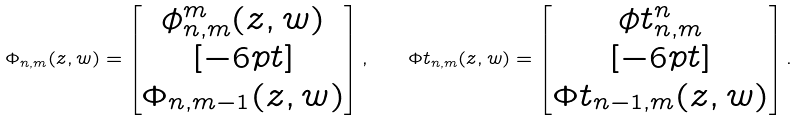<formula> <loc_0><loc_0><loc_500><loc_500>\Phi _ { n , m } ( z , w ) = \left [ \begin{matrix} \phi _ { n , m } ^ { m } ( z , w ) \\ [ - 6 p t ] \\ \Phi _ { n , m - 1 } ( z , w ) \end{matrix} \right ] , \quad \Phi t _ { n , m } ( z , w ) = \left [ \begin{matrix} \phi t _ { n , m } ^ { n } \\ [ - 6 p t ] \\ \Phi t _ { n - 1 , m } ( z , w ) \end{matrix} \right ] .</formula> 